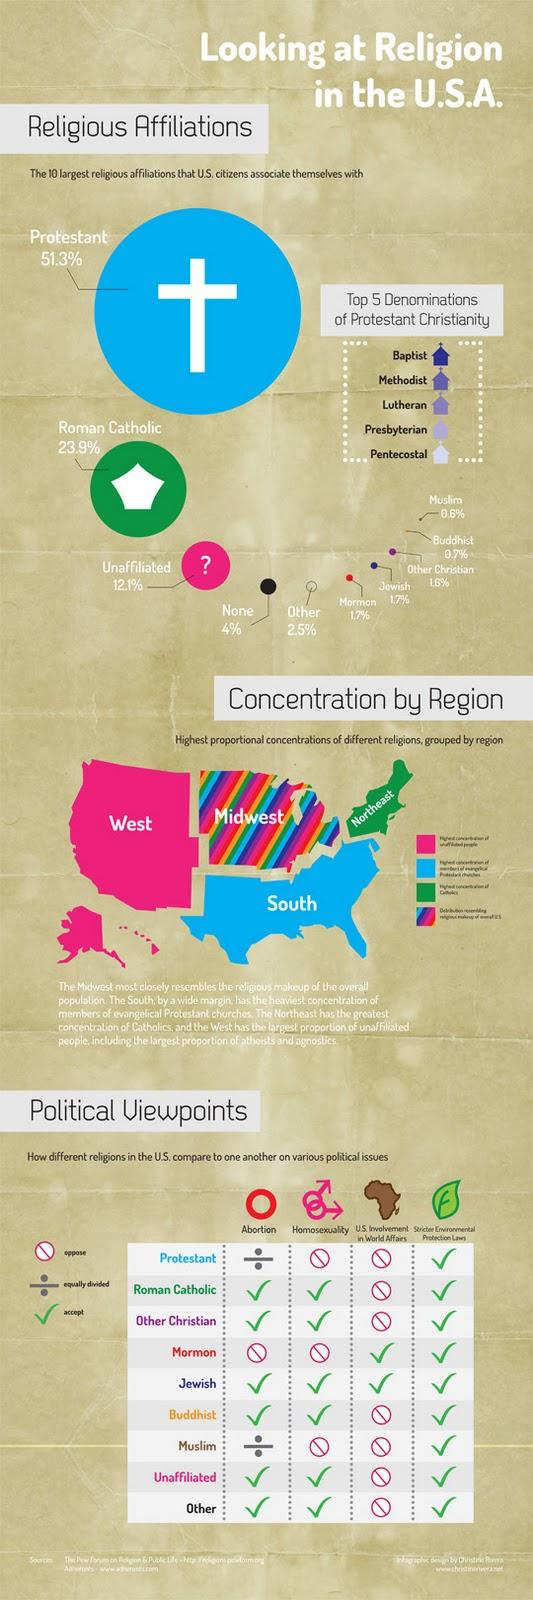Point out several critical features in this image. The green portion of the map displays the written notation 'Northeast.' According to the given data, Mormonism and Judaism contribute 1.7% to the religious affiliation of the United States. According to the data, the total percentage of religious affiliations contributed by the unaffiliated, none, and others is 18.6%. The color of the portion marked "South" is blue. The same is true for the portions marked "green," "pink," and any other combination of colors. The pink portion of the map contains the written text 'West.' 